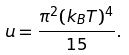Convert formula to latex. <formula><loc_0><loc_0><loc_500><loc_500>u = \frac { \pi ^ { 2 } ( k _ { B } T ) ^ { 4 } } { 1 5 } .</formula> 